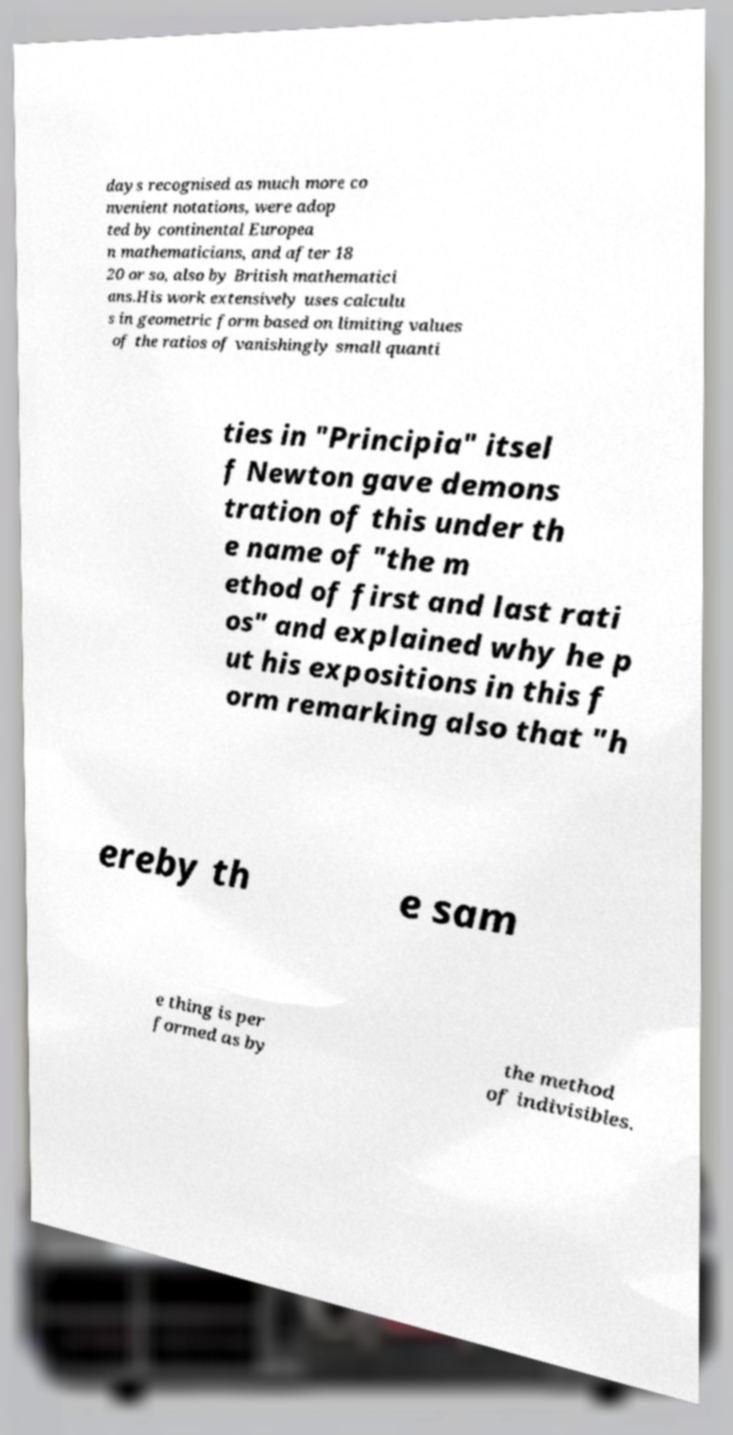What messages or text are displayed in this image? I need them in a readable, typed format. days recognised as much more co nvenient notations, were adop ted by continental Europea n mathematicians, and after 18 20 or so, also by British mathematici ans.His work extensively uses calculu s in geometric form based on limiting values of the ratios of vanishingly small quanti ties in "Principia" itsel f Newton gave demons tration of this under th e name of "the m ethod of first and last rati os" and explained why he p ut his expositions in this f orm remarking also that "h ereby th e sam e thing is per formed as by the method of indivisibles. 